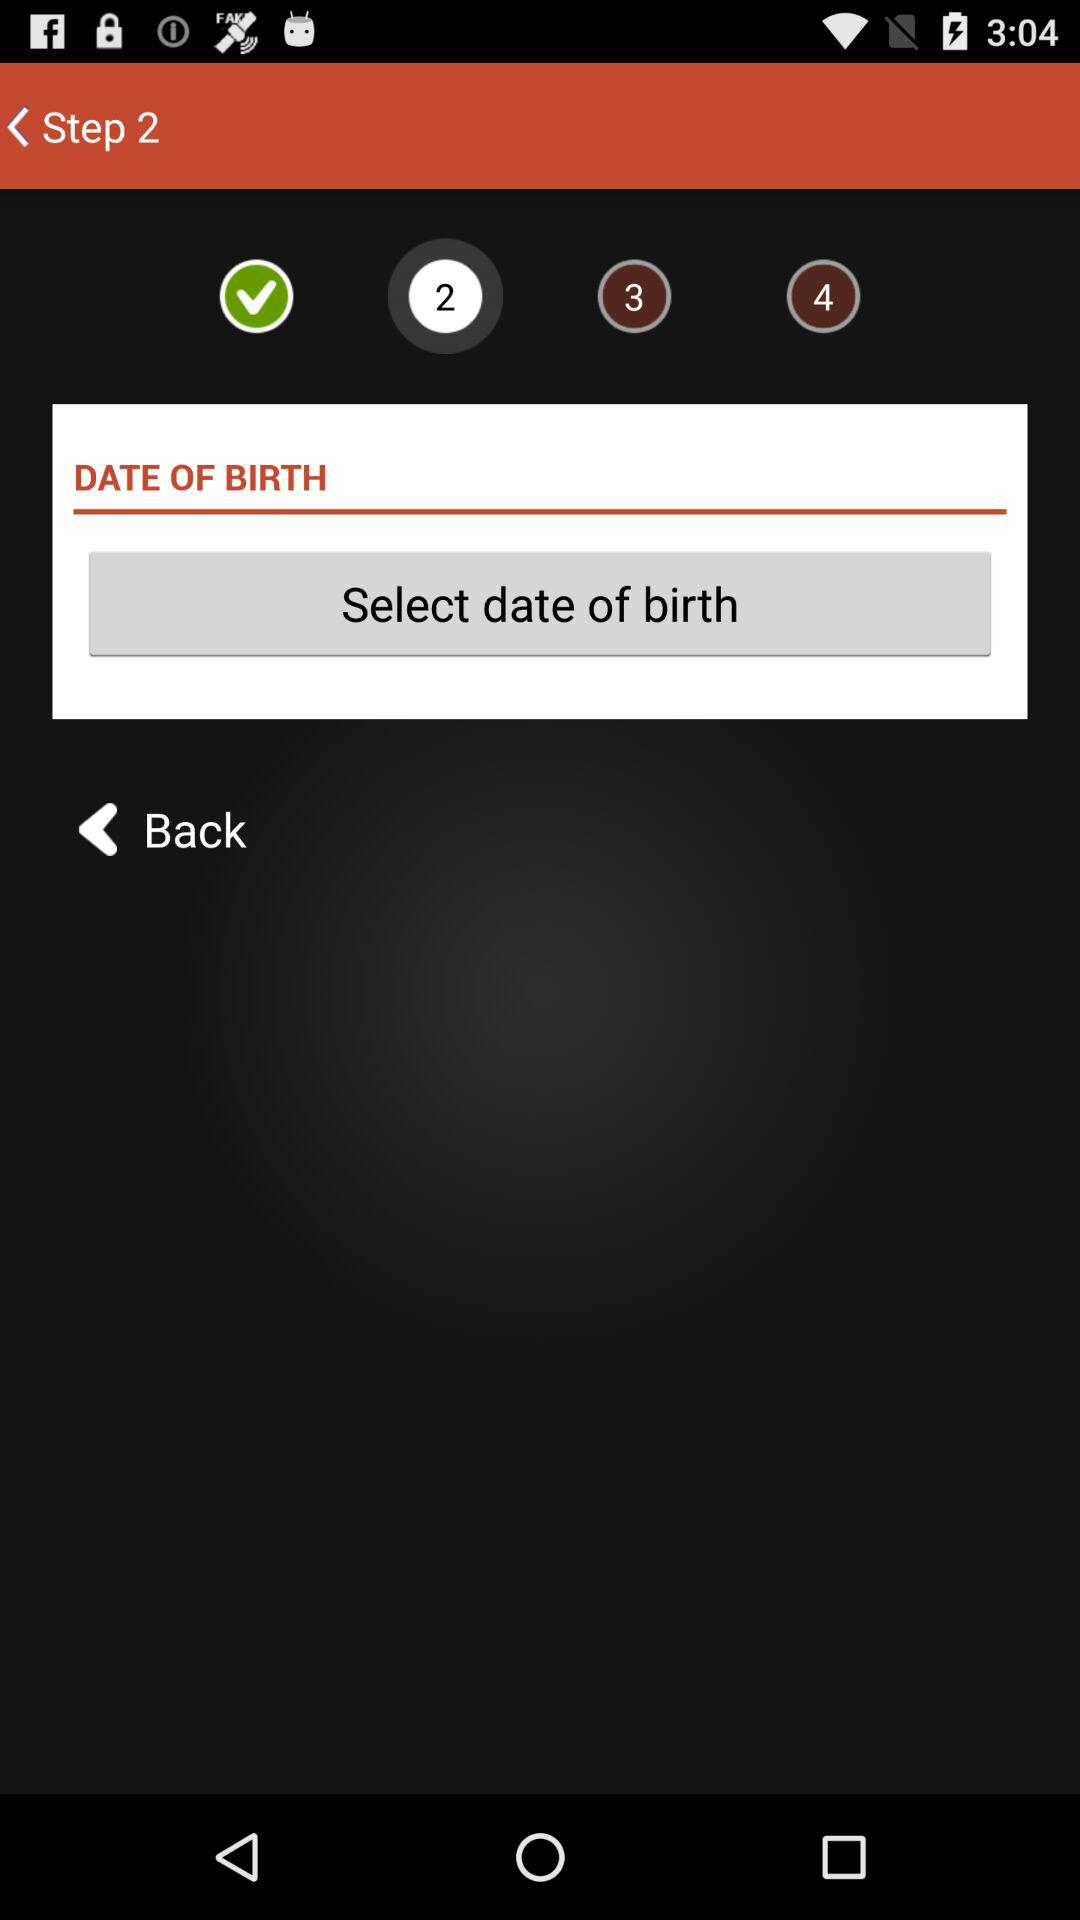How many steps are there in the process?
Answer the question using a single word or phrase. 4 